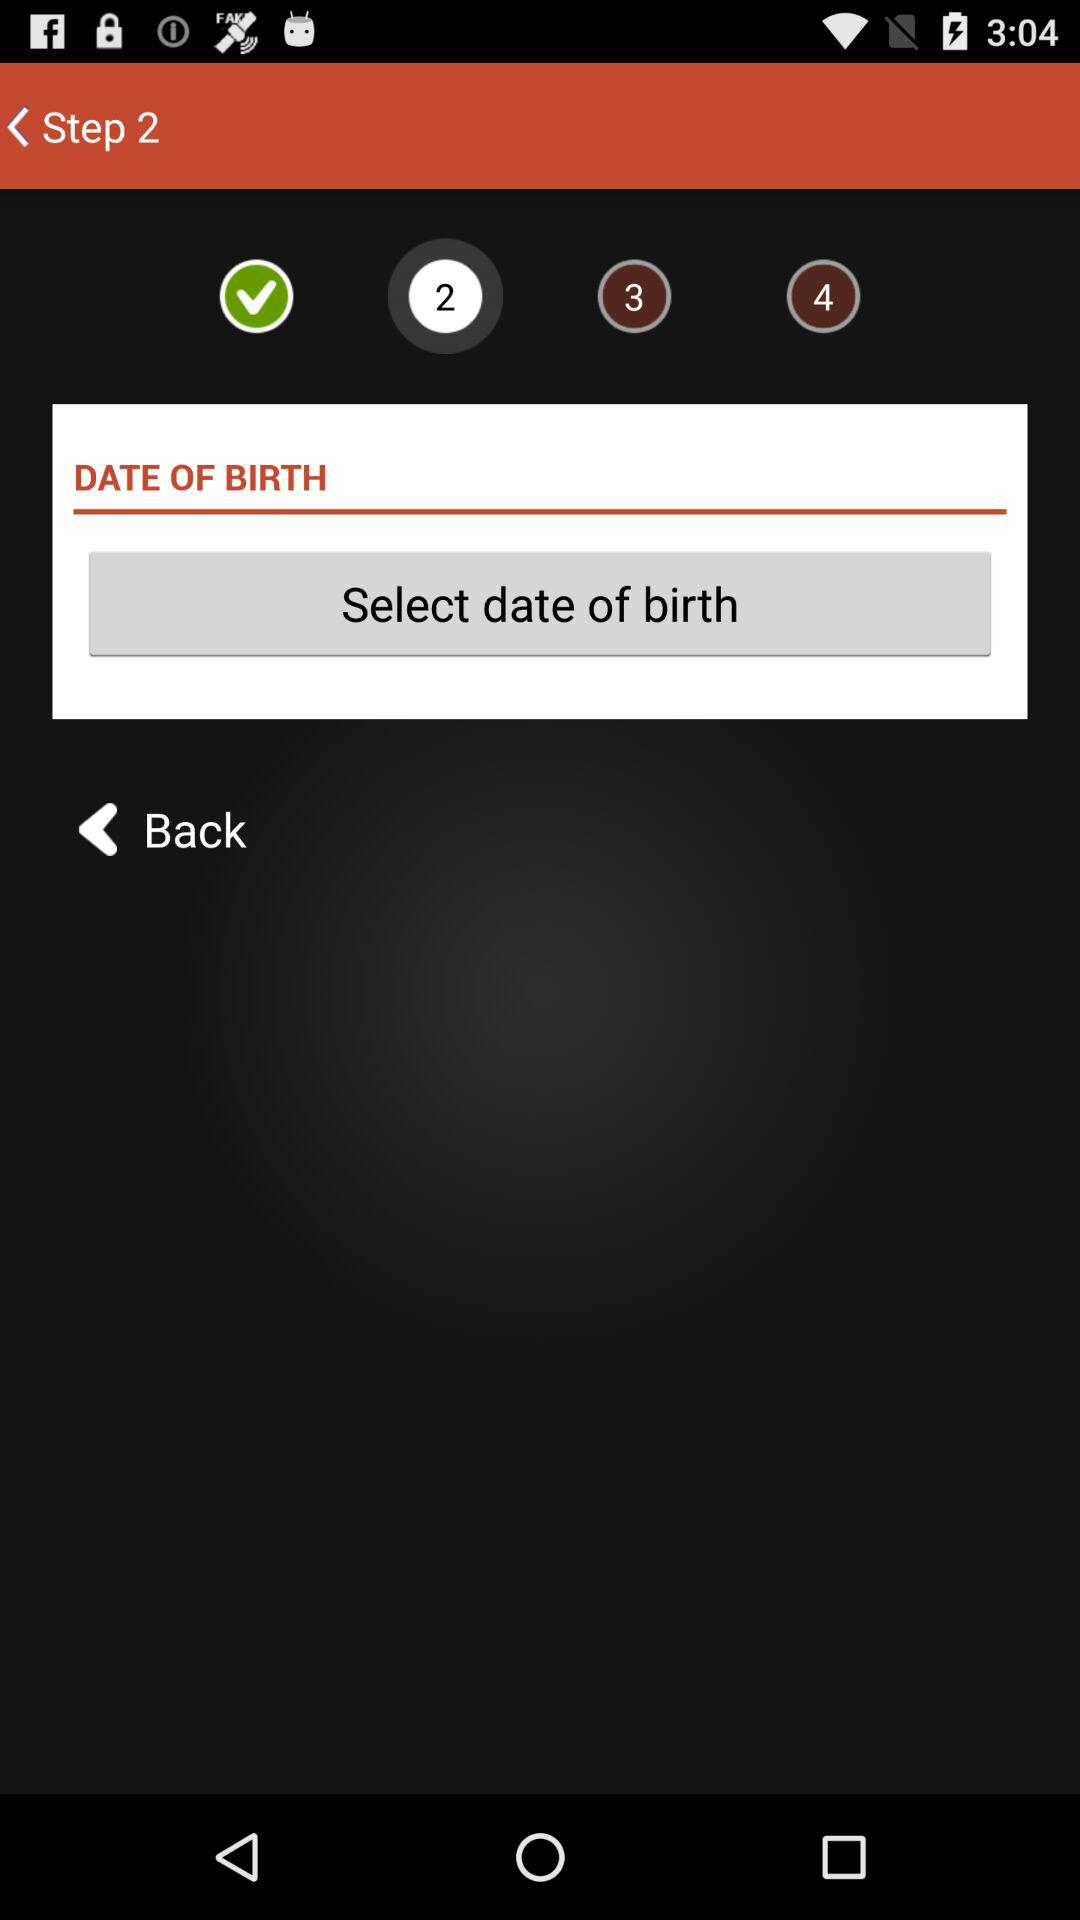How many steps are there in the process?
Answer the question using a single word or phrase. 4 